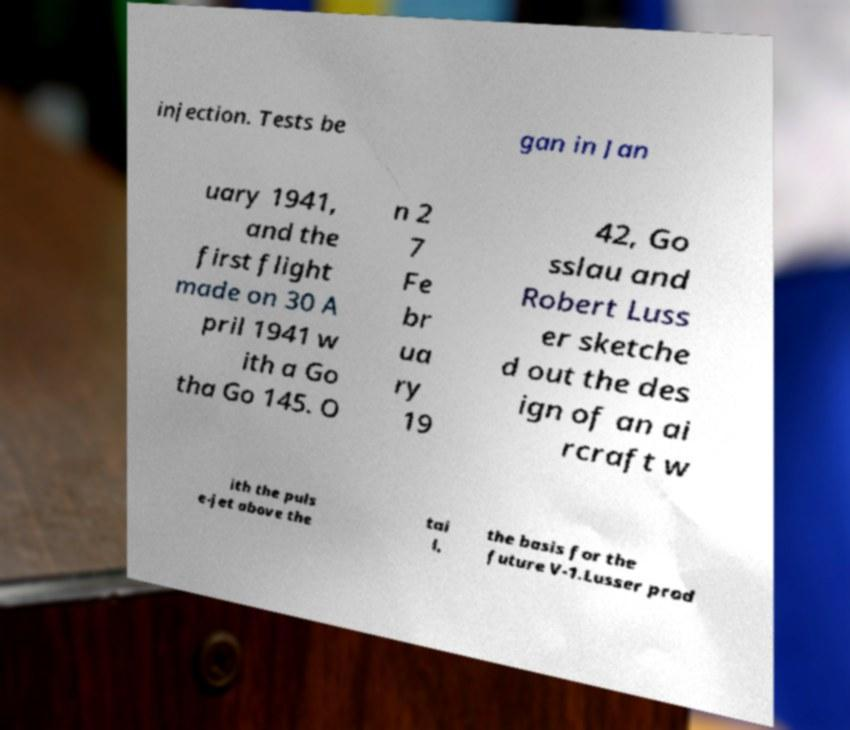There's text embedded in this image that I need extracted. Can you transcribe it verbatim? injection. Tests be gan in Jan uary 1941, and the first flight made on 30 A pril 1941 w ith a Go tha Go 145. O n 2 7 Fe br ua ry 19 42, Go sslau and Robert Luss er sketche d out the des ign of an ai rcraft w ith the puls e-jet above the tai l, the basis for the future V-1.Lusser prod 